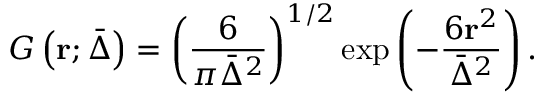Convert formula to latex. <formula><loc_0><loc_0><loc_500><loc_500>G \left ( r ; \bar { \Delta } \right ) = { { \left ( \frac { 6 } { \pi { { \bar { \Delta } } ^ { 2 } } } \right ) } ^ { 1 / 2 } } \exp \left ( - \frac { 6 { { r } ^ { 2 } } } { { { \bar { \Delta } } ^ { 2 } } } \right ) .</formula> 